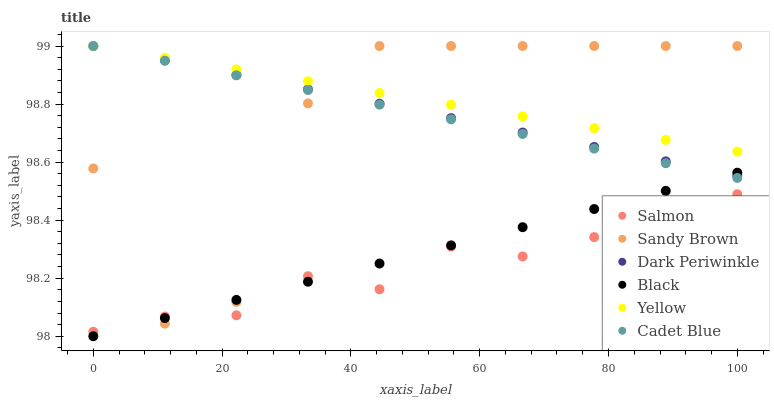Does Salmon have the minimum area under the curve?
Answer yes or no. Yes. Does Yellow have the maximum area under the curve?
Answer yes or no. Yes. Does Yellow have the minimum area under the curve?
Answer yes or no. No. Does Salmon have the maximum area under the curve?
Answer yes or no. No. Is Black the smoothest?
Answer yes or no. Yes. Is Sandy Brown the roughest?
Answer yes or no. Yes. Is Salmon the smoothest?
Answer yes or no. No. Is Salmon the roughest?
Answer yes or no. No. Does Black have the lowest value?
Answer yes or no. Yes. Does Salmon have the lowest value?
Answer yes or no. No. Does Dark Periwinkle have the highest value?
Answer yes or no. Yes. Does Salmon have the highest value?
Answer yes or no. No. Is Salmon less than Yellow?
Answer yes or no. Yes. Is Yellow greater than Salmon?
Answer yes or no. Yes. Does Dark Periwinkle intersect Black?
Answer yes or no. Yes. Is Dark Periwinkle less than Black?
Answer yes or no. No. Is Dark Periwinkle greater than Black?
Answer yes or no. No. Does Salmon intersect Yellow?
Answer yes or no. No. 